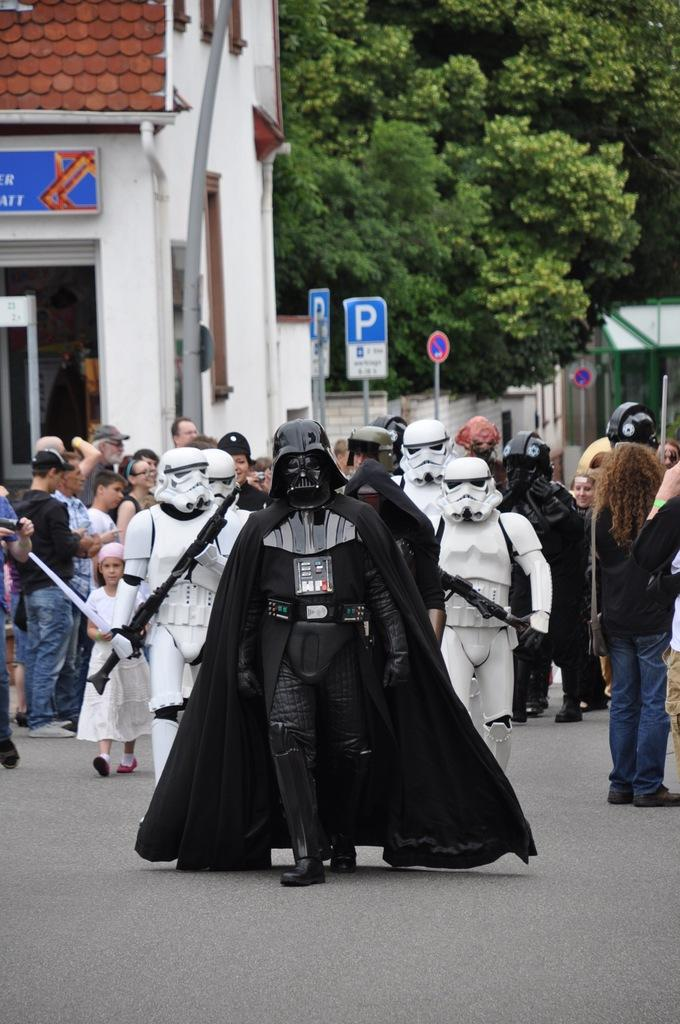How many people can be seen in the image? There are many people in the image. What can be seen in the background of the image? There are sign boards, buildings, and trees in the background of the image. What is visible at the bottom of the image? There is a road visible at the bottom of the image. What type of can is being used by the people in the image? There is no can visible in the image. What color is the skirt worn by the person in the image? There is no person wearing a skirt in the image. 